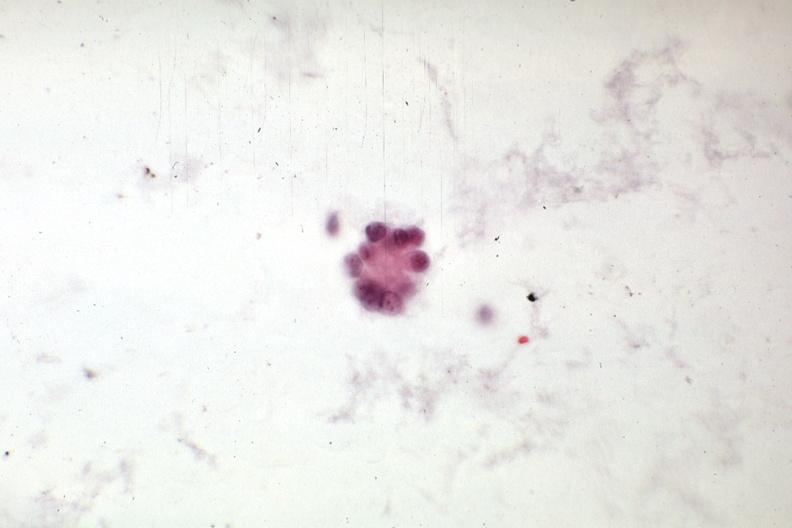s peritoneal fluid present?
Answer the question using a single word or phrase. Yes 